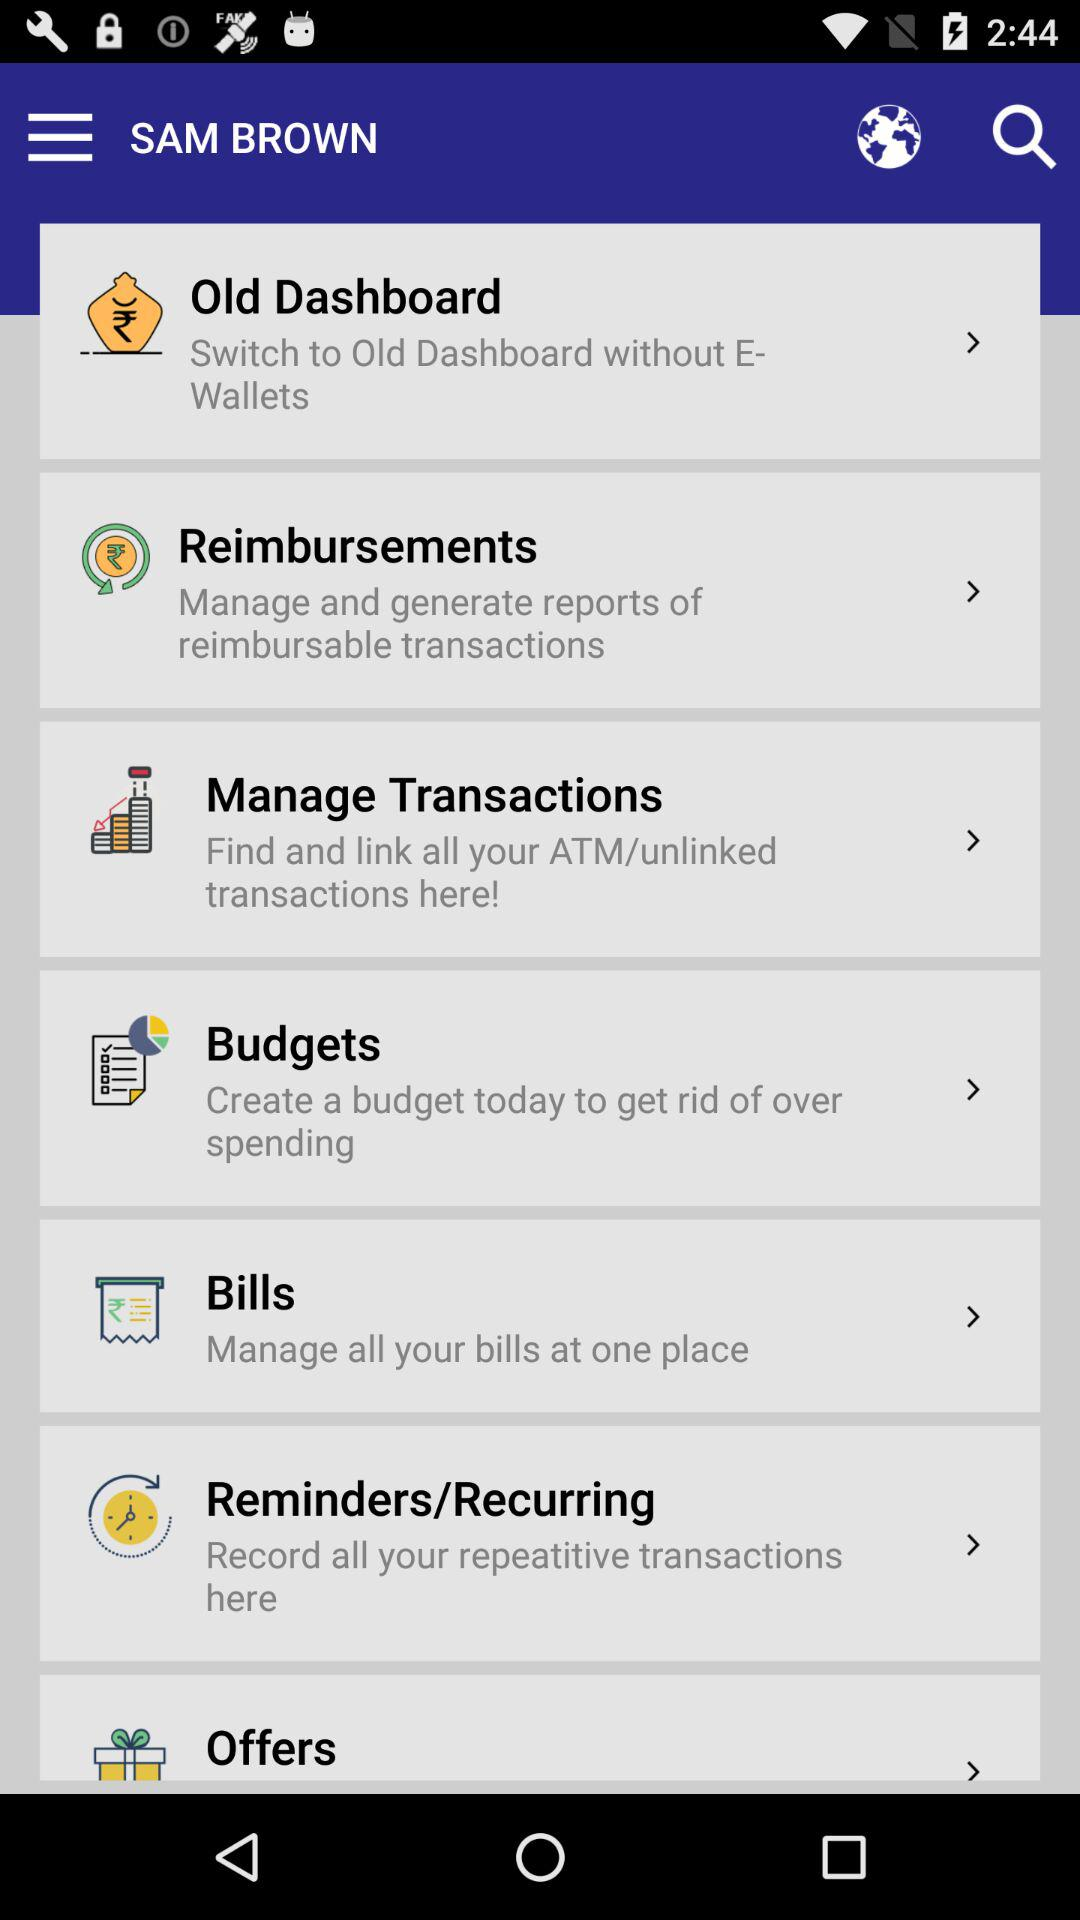What is the user name? The user name is Sam brown. 